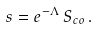Convert formula to latex. <formula><loc_0><loc_0><loc_500><loc_500>s = e ^ { - \Lambda } \, S _ { c o } \, .</formula> 